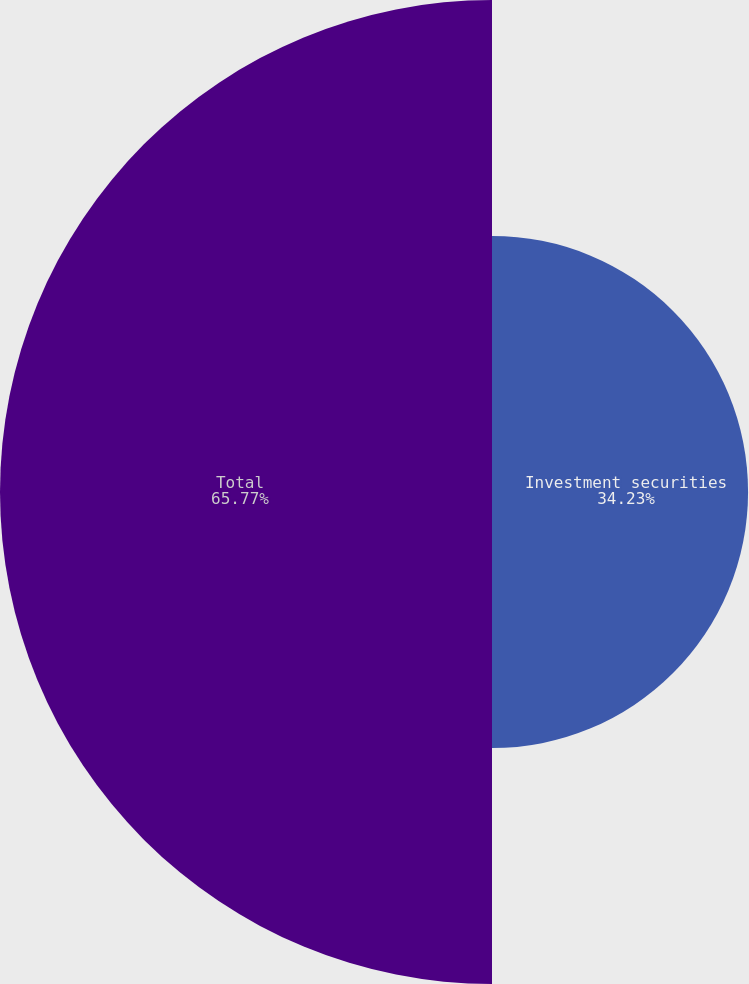Convert chart. <chart><loc_0><loc_0><loc_500><loc_500><pie_chart><fcel>Investment securities<fcel>Total<nl><fcel>34.23%<fcel>65.77%<nl></chart> 